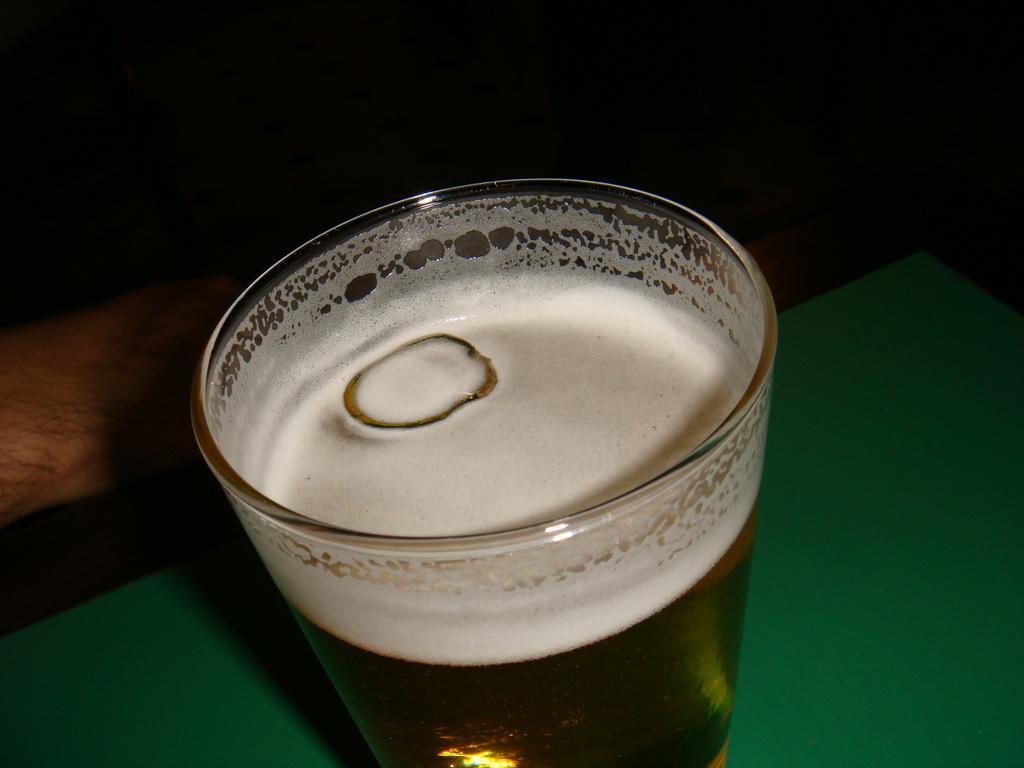Describe this image in one or two sentences. In the image as we can see, this glass is filled with a liquid substance, and this is a human hand. 